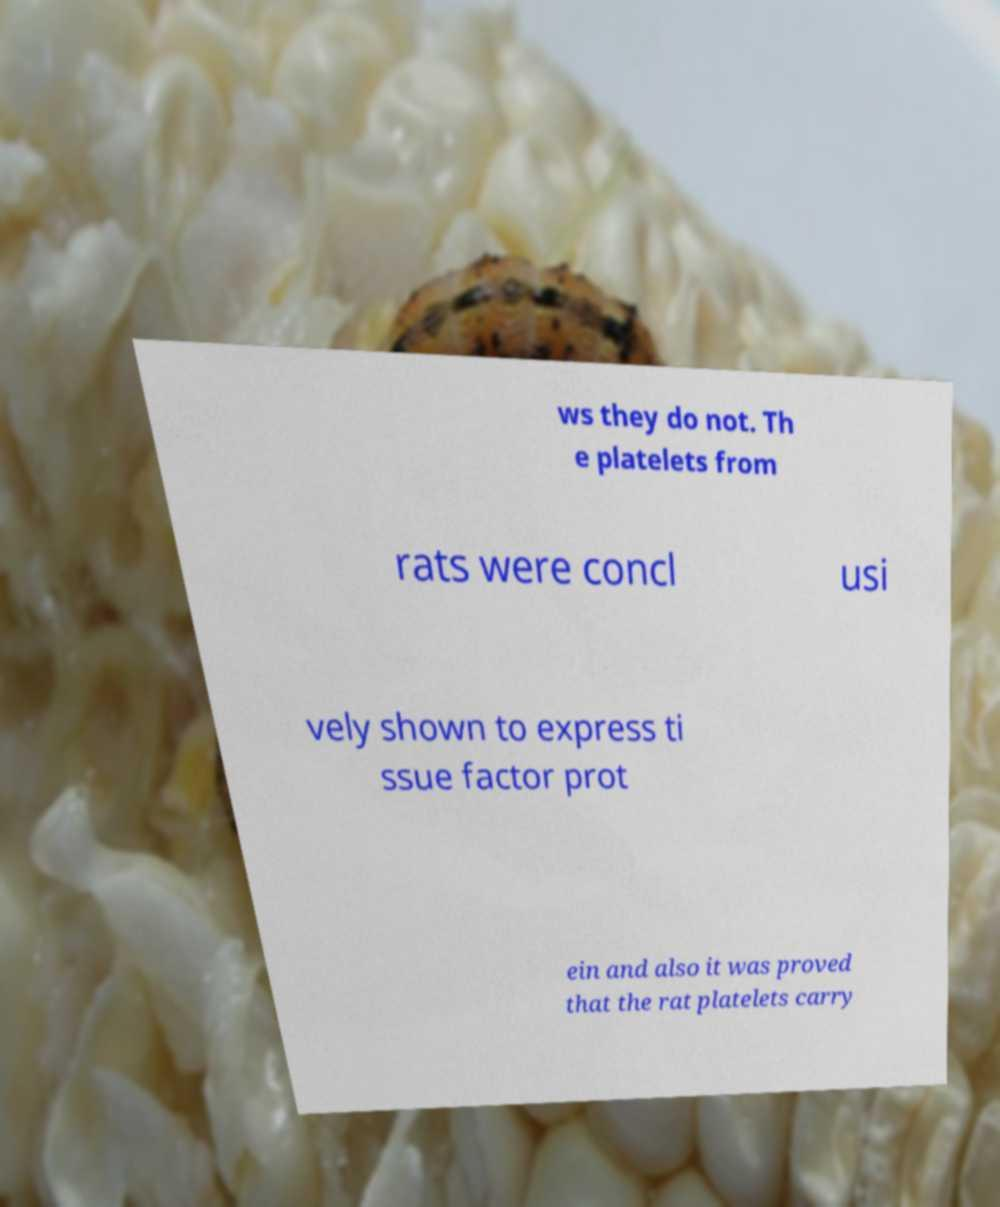Please identify and transcribe the text found in this image. ws they do not. Th e platelets from rats were concl usi vely shown to express ti ssue factor prot ein and also it was proved that the rat platelets carry 